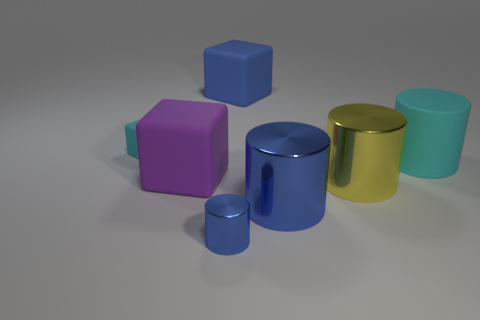Is there a small sphere of the same color as the rubber cylinder?
Your response must be concise. No. Is the blue matte object the same shape as the tiny cyan object?
Your response must be concise. Yes. What size is the cylinder that is the same color as the tiny matte cube?
Keep it short and to the point. Large. How many small cyan matte things are on the right side of the tiny thing in front of the big yellow thing?
Provide a short and direct response. 0. How many blue objects are to the left of the big blue cube and behind the big yellow metallic thing?
Ensure brevity in your answer.  0. What number of things are either blue metal cylinders or objects that are right of the blue cube?
Keep it short and to the point. 4. There is another blue cylinder that is the same material as the tiny blue cylinder; what is its size?
Give a very brief answer. Large. There is a large shiny thing that is behind the blue shiny cylinder that is behind the tiny blue object; what shape is it?
Provide a short and direct response. Cylinder. How many cyan things are either big objects or blocks?
Your answer should be compact. 2. Are there any large cyan objects that are behind the rubber thing in front of the big matte thing that is right of the yellow thing?
Provide a succinct answer. Yes. 